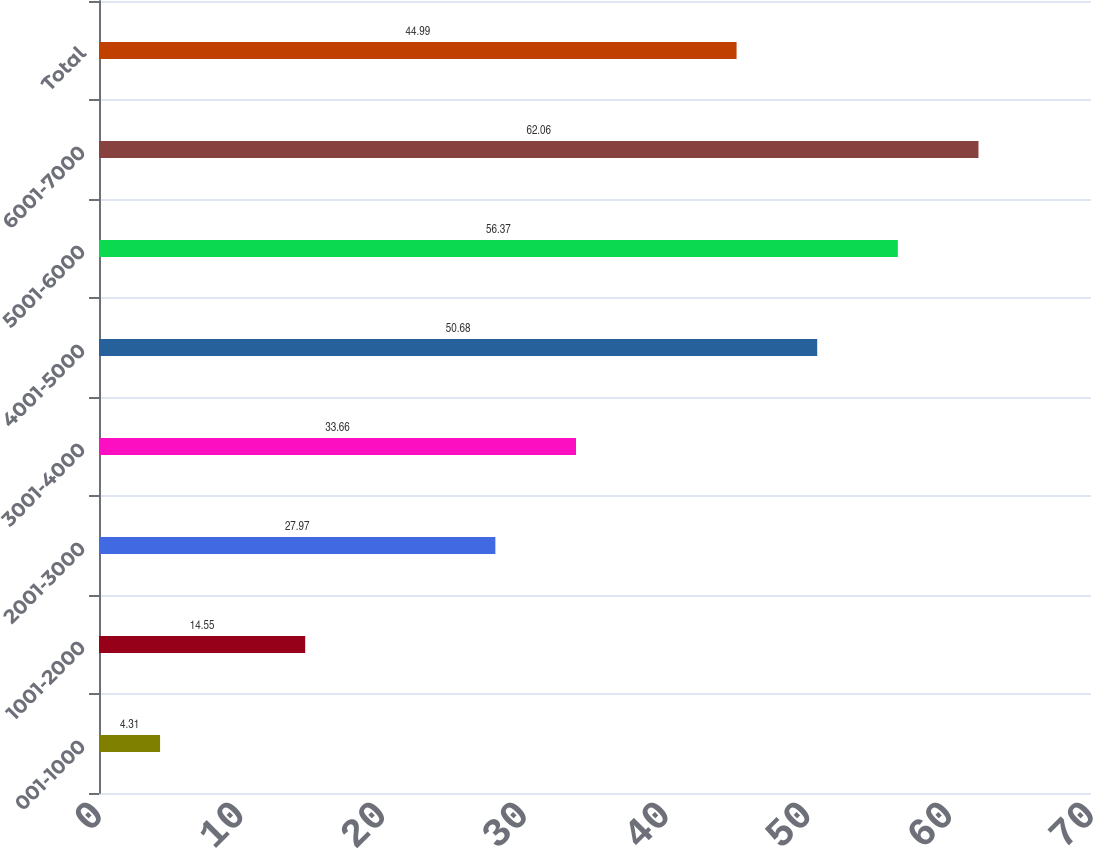Convert chart. <chart><loc_0><loc_0><loc_500><loc_500><bar_chart><fcel>001-1000<fcel>1001-2000<fcel>2001-3000<fcel>3001-4000<fcel>4001-5000<fcel>5001-6000<fcel>6001-7000<fcel>Total<nl><fcel>4.31<fcel>14.55<fcel>27.97<fcel>33.66<fcel>50.68<fcel>56.37<fcel>62.06<fcel>44.99<nl></chart> 